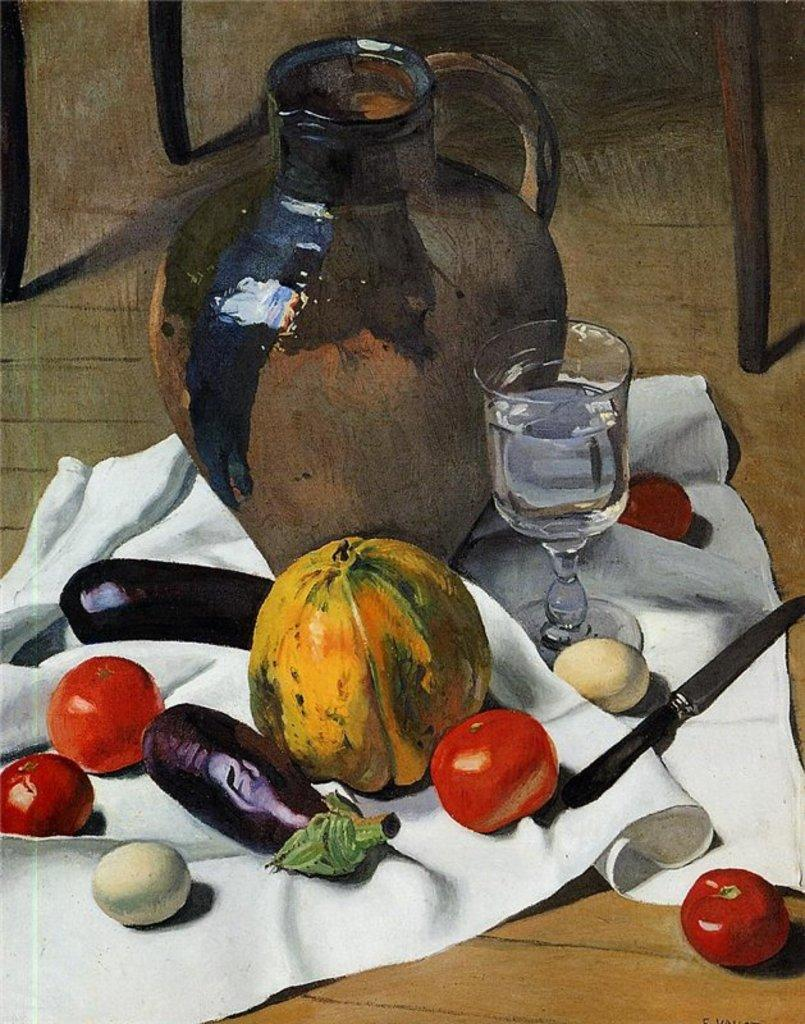What type of artwork is the image? The image is an oil painting. What object can be seen in the image? There is a pot in the image. What utensil is present in the image? There is a knife in the image. What type of material is the cloth made of in the image? The cloth in the image is not specified, but it is present. What type of beverage is in the glass in the image? There is a glass of water in the image. What type of food items are present in the image? There are vegetables and eggs in the image. What type of badge is visible on the vegetables in the image? There is no badge present on the vegetables in the image. What is the way the eggs are arranged in the image? The way the eggs are arranged in the image is not specified, but they are present. What is the size of the pot in the image? The size of the pot in the image is not specified, but it is present. 